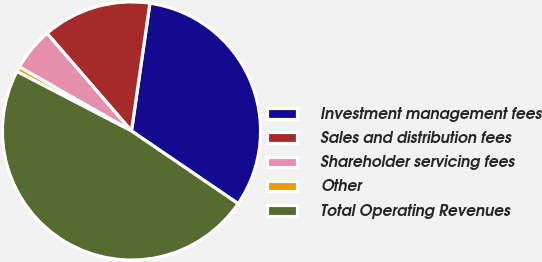Convert chart. <chart><loc_0><loc_0><loc_500><loc_500><pie_chart><fcel>Investment management fees<fcel>Sales and distribution fees<fcel>Shareholder servicing fees<fcel>Other<fcel>Total Operating Revenues<nl><fcel>32.24%<fcel>13.63%<fcel>5.39%<fcel>0.64%<fcel>48.1%<nl></chart> 